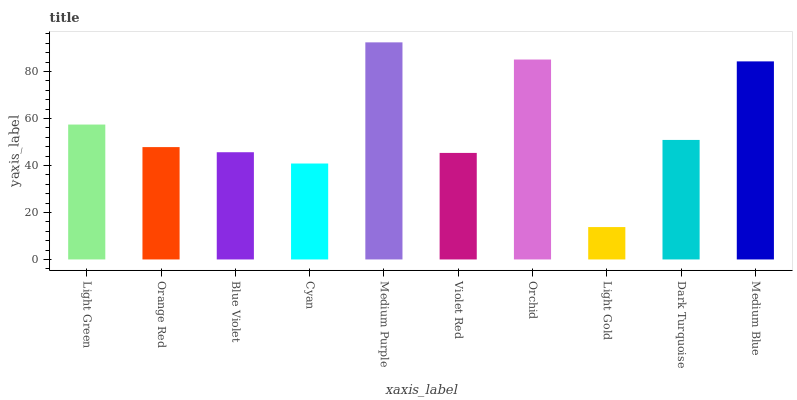Is Light Gold the minimum?
Answer yes or no. Yes. Is Medium Purple the maximum?
Answer yes or no. Yes. Is Orange Red the minimum?
Answer yes or no. No. Is Orange Red the maximum?
Answer yes or no. No. Is Light Green greater than Orange Red?
Answer yes or no. Yes. Is Orange Red less than Light Green?
Answer yes or no. Yes. Is Orange Red greater than Light Green?
Answer yes or no. No. Is Light Green less than Orange Red?
Answer yes or no. No. Is Dark Turquoise the high median?
Answer yes or no. Yes. Is Orange Red the low median?
Answer yes or no. Yes. Is Light Green the high median?
Answer yes or no. No. Is Violet Red the low median?
Answer yes or no. No. 